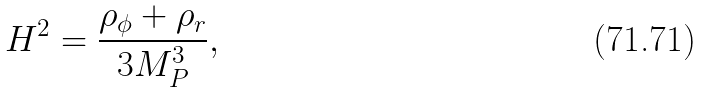<formula> <loc_0><loc_0><loc_500><loc_500>H ^ { 2 } = \frac { \rho _ { \phi } + \rho _ { r } } { 3 M _ { P } ^ { 3 } } ,</formula> 